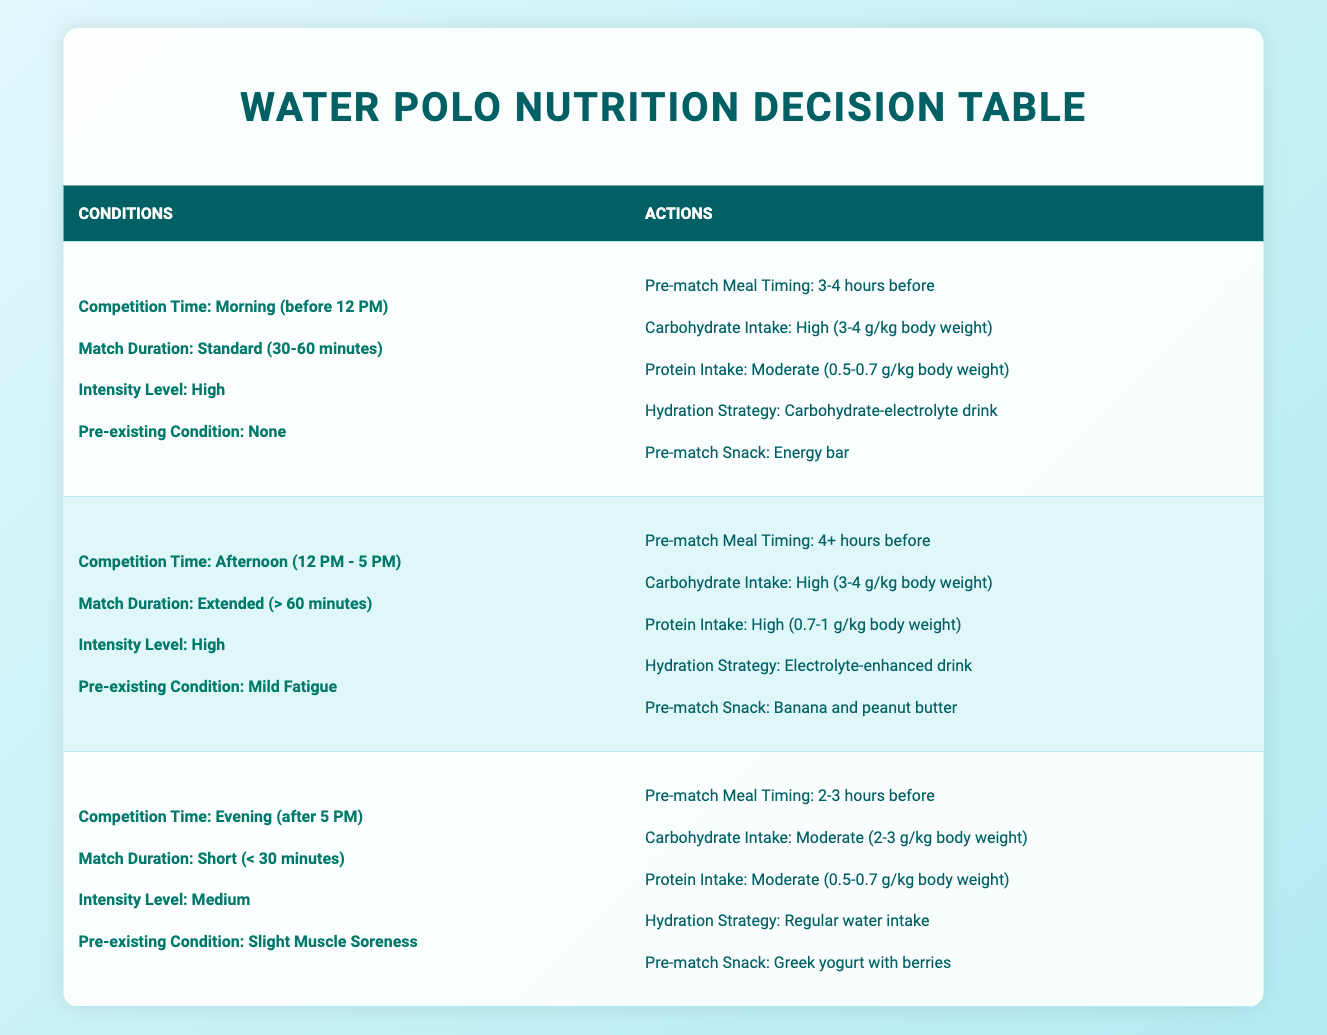What is the recommended pre-match meal timing for a morning match lasting 30-60 minutes with high intensity? According to the table, for a morning match (before 12 PM) that lasts 30-60 minutes and has high intensity, the pre-match meal timing is 3-4 hours before.
Answer: 3-4 hours before Is the carbohydrate intake for an afternoon match with mild fatigue high or moderate? The table indicates that for an afternoon match (12 PM - 5 PM) with mild fatigue, the carbohydrate intake is high (3-4 g/kg body weight).
Answer: High What snack is suggested for an evening match with slight muscle soreness? The table specifies that for an evening match (after 5 PM) with slight muscle soreness, the recommended pre-match snack is Greek yogurt with berries.
Answer: Greek yogurt with berries How does the protein intake for a standard duration morning match compare to an extended afternoon match? In the morning match, the protein intake is moderate (0.5-0.7 g/kg body weight), while for the extended afternoon match, it is high (0.7-1 g/kg body weight). Therefore, the protein intake for the afternoon match is higher than for the morning match.
Answer: Higher in the afternoon match Is there a hydration strategy for a short evening match? Yes, for a short evening match lasting less than 30 minutes, the hydration strategy recommended is regular water intake.
Answer: Yes If a player has mild fatigue for an afternoon match, what is the hydration strategy? According to the table, when the player has mild fatigue for an afternoon match, the hydration strategy is an electrolyte-enhanced drink.
Answer: Electrolyte-enhanced drink What is the total carbohydrate intake suggested for a high-intensity extended afternoon match and a medium-intensity short evening match? The carbohydrate intake for the high-intensity extended afternoon match is high (3-4 g/kg body weight). The moderate intake for the medium-intensity short evening match is 2-3 g/kg body weight. Therefore, combining these two intake suggestions would average between high (3) and moderate (2), approximately 2.5 g/kg body weight.
Answer: Approximately 2.5 g/kg body weight What is the pre-match snack for a standard duration match with no pre-existing conditions? For a standard duration match (30-60 minutes) with no pre-existing conditions in the morning, the pre-match snack is an energy bar.
Answer: Energy bar If all matches are high intensity, what shared action is there for pre-match meal timing in terms of timing? The only shared pre-match meal timing for all high-intensity matches is that they are either 3-4 hours or more. The specific timing is either 3-4 hours before in the morning or 4+ hours in the afternoon.
Answer: 3-4 hours or 4+ hours before 